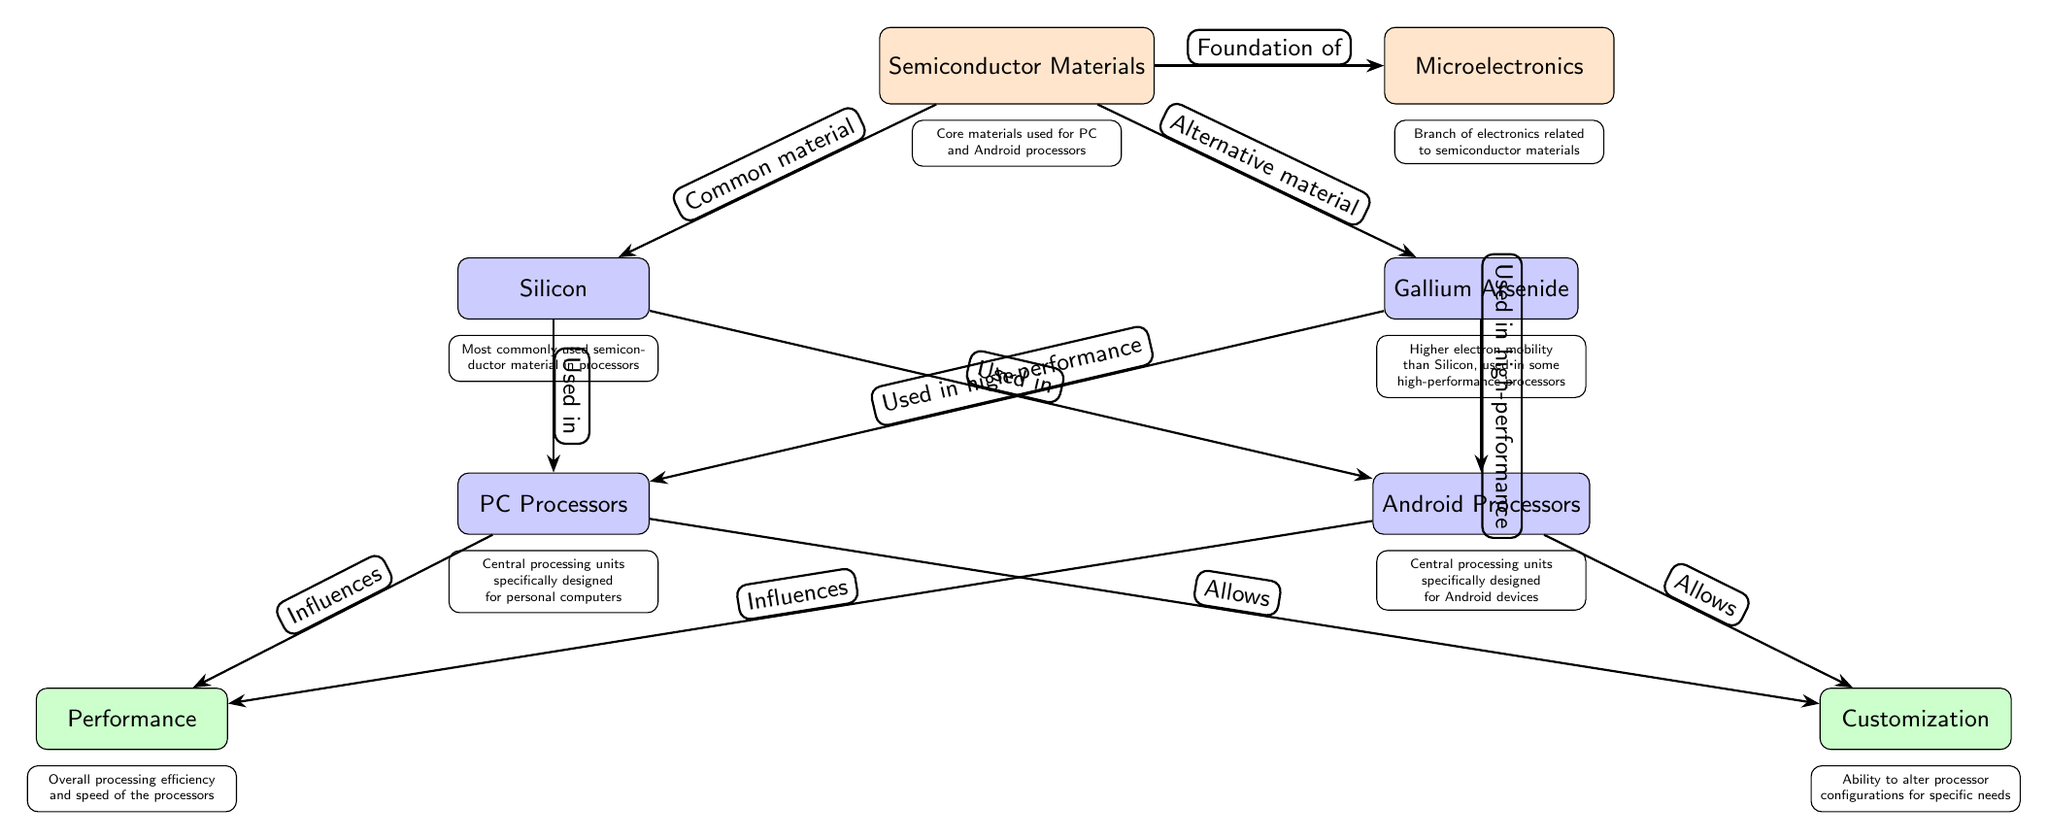What is the common semiconductor material used in processors? The diagram indicates that Silicon is the most commonly used semiconductor material referenced directly to the node labeled "Common material".
Answer: Silicon What branches from "Semiconductor Materials" to "Microelectronics"? The diagram shows that "Semiconductor Materials" leads directly to "Microelectronics" with the edge labeled "Foundation of".
Answer: Foundation of Which semiconductor material is described as having higher electron mobility? The node labeled "Gallium Arsenide" highlights the property's mention, indicating higher electron mobility compared to Silicon.
Answer: Gallium Arsenide What influences the performance of both PC and Android processors? According to the diagram, both "PC Processors" and "Android Processors" directly influence "Performance," indicating that this outcome is a combined effect.
Answer: Performance How many types of processors are directly mentioned in the diagram? The diagram explicitly mentions two types of processors: "PC Processors" and "Android Processors", which can be counted from their respective nodes.
Answer: Two What allows customization in processor designs for PCs and Android? The arrows from "PC Processors" and "Android Processors" point to "Customization," demonstrating that the ability to alter configurations is facilitated by these processors.
Answer: Customization Which material is primarily used in Android processors? The node "Silicon" indicates that it is used in Android processors based on the direct edge connecting them.
Answer: Silicon What is the relationship between "Gallium Arsenide" and high-performance processors? The edges extending from "Gallium Arsenide" show its use in both "PC Processors" and "Android Processors" specifically for high-performance applications, illustrating this relationship.
Answer: Used in high-performance How does Silicon relate to the usage in processors? The arrows connecting "Silicon" to both types of processors indicate that it is used in them, representing its essential role in processor functioning.
Answer: Used in 